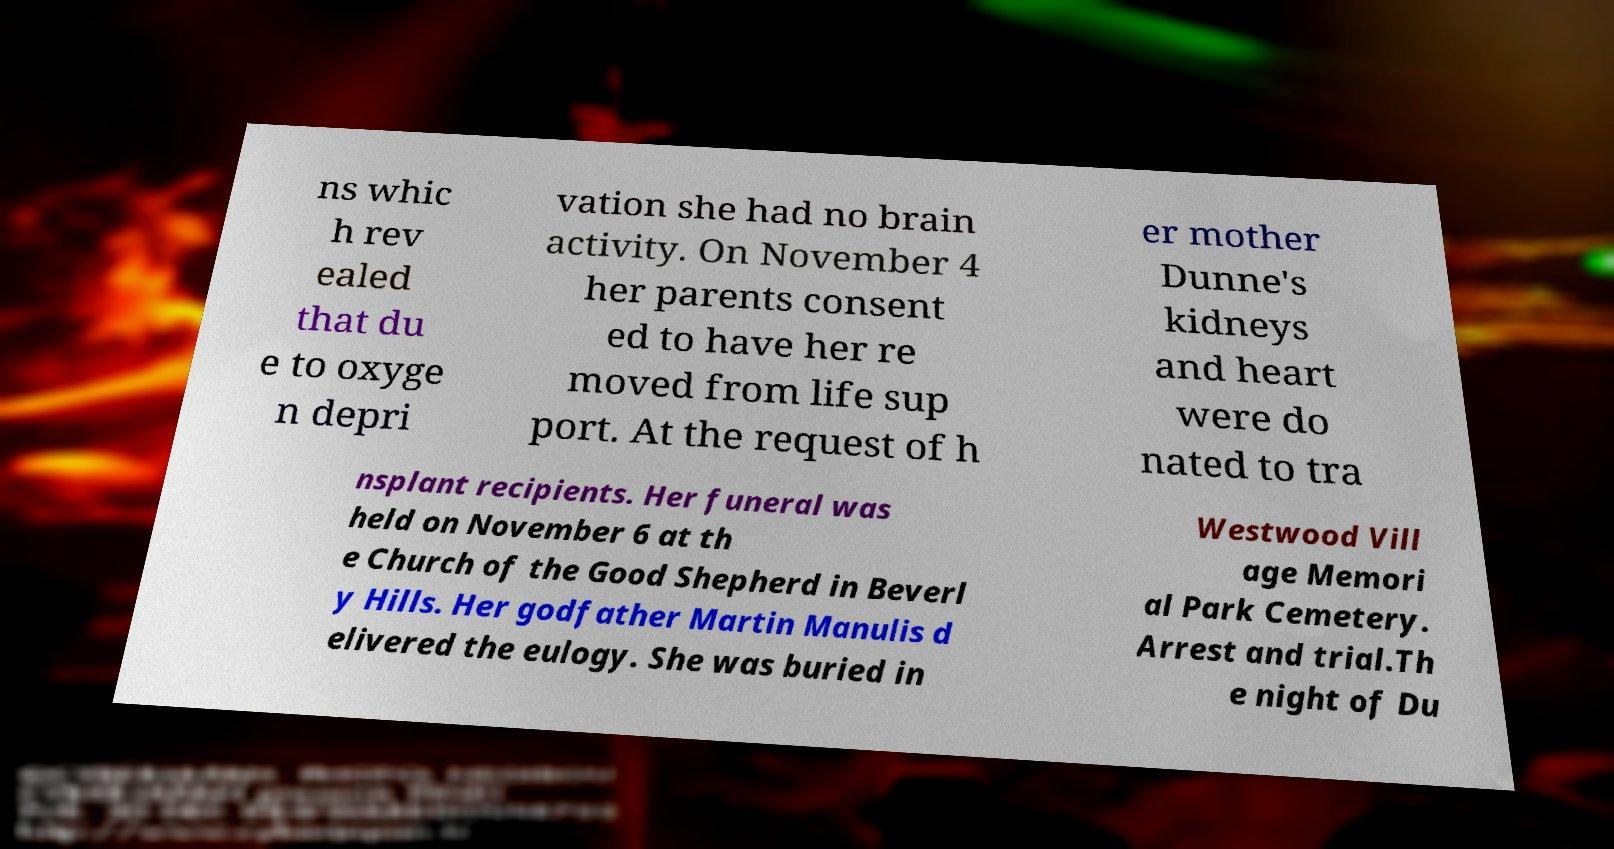I need the written content from this picture converted into text. Can you do that? ns whic h rev ealed that du e to oxyge n depri vation she had no brain activity. On November 4 her parents consent ed to have her re moved from life sup port. At the request of h er mother Dunne's kidneys and heart were do nated to tra nsplant recipients. Her funeral was held on November 6 at th e Church of the Good Shepherd in Beverl y Hills. Her godfather Martin Manulis d elivered the eulogy. She was buried in Westwood Vill age Memori al Park Cemetery. Arrest and trial.Th e night of Du 